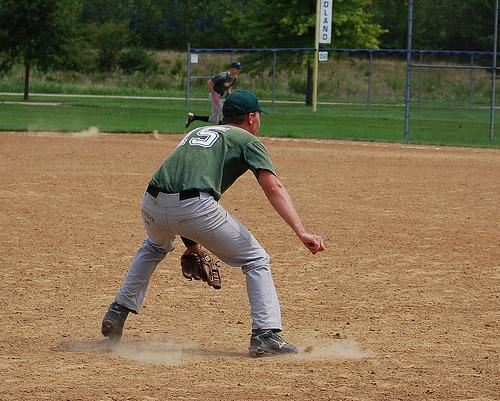How many people are there?
Give a very brief answer. 2. 